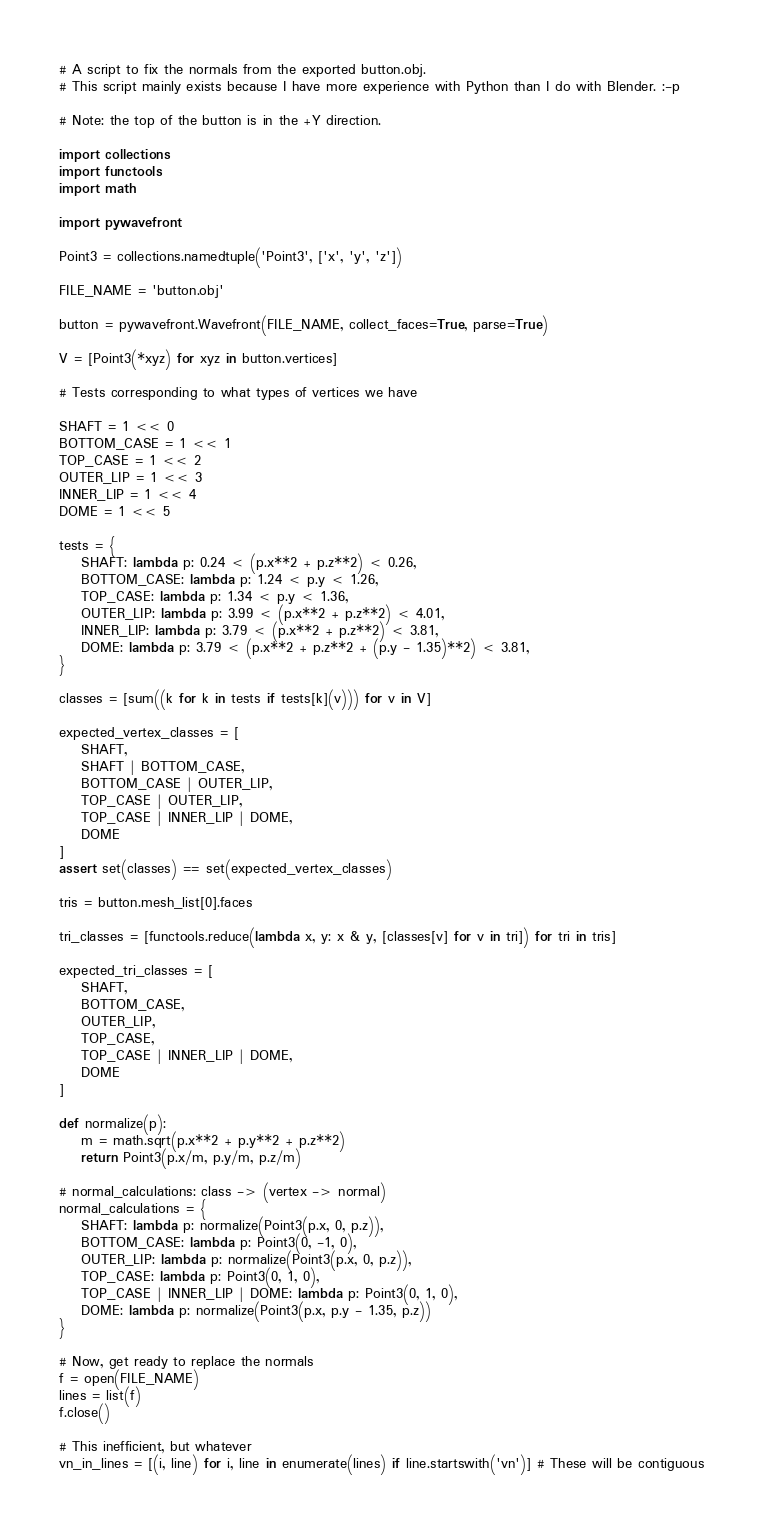Convert code to text. <code><loc_0><loc_0><loc_500><loc_500><_Python_># A script to fix the normals from the exported button.obj.
# This script mainly exists because I have more experience with Python than I do with Blender. :-p

# Note: the top of the button is in the +Y direction.

import collections
import functools
import math

import pywavefront

Point3 = collections.namedtuple('Point3', ['x', 'y', 'z'])

FILE_NAME = 'button.obj'

button = pywavefront.Wavefront(FILE_NAME, collect_faces=True, parse=True)

V = [Point3(*xyz) for xyz in button.vertices]

# Tests corresponding to what types of vertices we have

SHAFT = 1 << 0
BOTTOM_CASE = 1 << 1
TOP_CASE = 1 << 2
OUTER_LIP = 1 << 3
INNER_LIP = 1 << 4
DOME = 1 << 5

tests = {
    SHAFT: lambda p: 0.24 < (p.x**2 + p.z**2) < 0.26,
    BOTTOM_CASE: lambda p: 1.24 < p.y < 1.26,
    TOP_CASE: lambda p: 1.34 < p.y < 1.36,
    OUTER_LIP: lambda p: 3.99 < (p.x**2 + p.z**2) < 4.01,
    INNER_LIP: lambda p: 3.79 < (p.x**2 + p.z**2) < 3.81,
    DOME: lambda p: 3.79 < (p.x**2 + p.z**2 + (p.y - 1.35)**2) < 3.81,
}

classes = [sum((k for k in tests if tests[k](v))) for v in V]

expected_vertex_classes = [
    SHAFT,
    SHAFT | BOTTOM_CASE,
    BOTTOM_CASE | OUTER_LIP,
    TOP_CASE | OUTER_LIP,
    TOP_CASE | INNER_LIP | DOME,
    DOME
]
assert set(classes) == set(expected_vertex_classes)

tris = button.mesh_list[0].faces

tri_classes = [functools.reduce(lambda x, y: x & y, [classes[v] for v in tri]) for tri in tris]

expected_tri_classes = [
    SHAFT,
    BOTTOM_CASE,
    OUTER_LIP,
    TOP_CASE,
    TOP_CASE | INNER_LIP | DOME,
    DOME
]

def normalize(p):
    m = math.sqrt(p.x**2 + p.y**2 + p.z**2)
    return Point3(p.x/m, p.y/m, p.z/m)

# normal_calculations: class -> (vertex -> normal)
normal_calculations = {
    SHAFT: lambda p: normalize(Point3(p.x, 0, p.z)),
    BOTTOM_CASE: lambda p: Point3(0, -1, 0),
    OUTER_LIP: lambda p: normalize(Point3(p.x, 0, p.z)),
    TOP_CASE: lambda p: Point3(0, 1, 0),
    TOP_CASE | INNER_LIP | DOME: lambda p: Point3(0, 1, 0),
    DOME: lambda p: normalize(Point3(p.x, p.y - 1.35, p.z))
}

# Now, get ready to replace the normals
f = open(FILE_NAME)
lines = list(f)
f.close()

# This inefficient, but whatever
vn_in_lines = [(i, line) for i, line in enumerate(lines) if line.startswith('vn')] # These will be contiguous</code> 